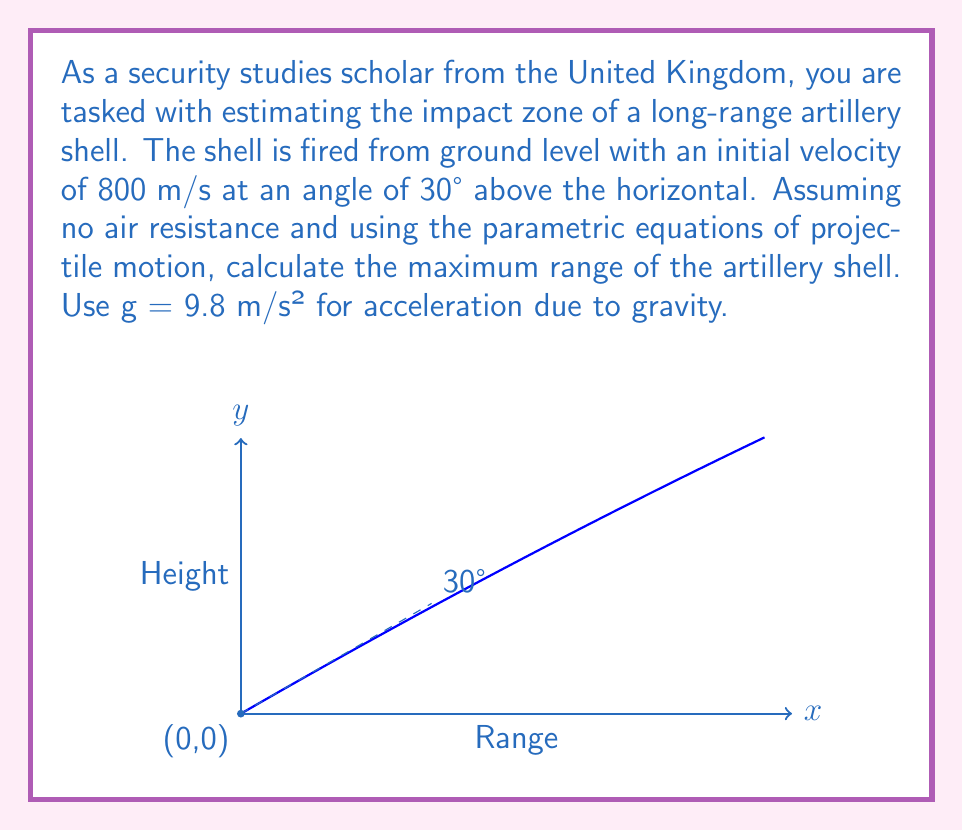Provide a solution to this math problem. Let's approach this step-by-step using the parametric equations of projectile motion:

1) The parametric equations for projectile motion are:
   $$x(t) = v_0 \cos(\theta) t$$
   $$y(t) = v_0 \sin(\theta) t - \frac{1}{2}gt^2$$

   Where $v_0$ is the initial velocity, $\theta$ is the launch angle, and $g$ is the acceleration due to gravity.

2) To find the maximum range, we need to find the time when the projectile hits the ground (y = 0). We can do this by solving the equation:
   $$0 = v_0 \sin(\theta) t - \frac{1}{2}gt^2$$

3) This is a quadratic equation. The positive root of this equation gives us the time of flight:
   $$t = \frac{2v_0 \sin(\theta)}{g}$$

4) Substituting the given values:
   $$t = \frac{2 \cdot 800 \cdot \sin(30°)}{9.8} \approx 81.65 \text{ seconds}$$

5) Now that we have the time of flight, we can substitute this into the equation for x to find the maximum range:
   $$x_{max} = v_0 \cos(\theta) t$$

6) Substituting the values:
   $$x_{max} = 800 \cdot \cos(30°) \cdot 81.65 \approx 56,568 \text{ meters}$$

Therefore, the maximum range of the artillery shell is approximately 56,568 meters or about 56.57 kilometers.
Answer: 56.57 km 